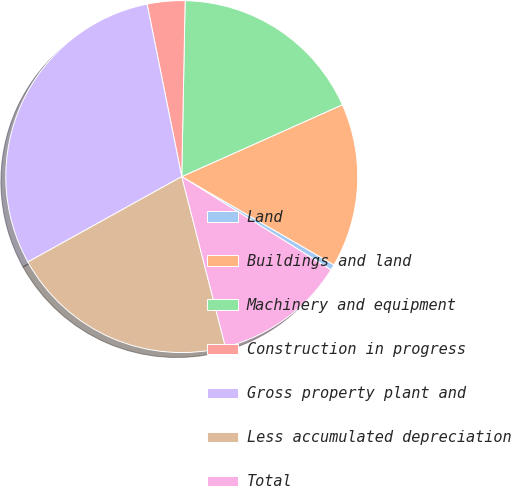<chart> <loc_0><loc_0><loc_500><loc_500><pie_chart><fcel>Land<fcel>Buildings and land<fcel>Machinery and equipment<fcel>Construction in progress<fcel>Gross property plant and<fcel>Less accumulated depreciation<fcel>Total<nl><fcel>0.52%<fcel>15.06%<fcel>18.0%<fcel>3.46%<fcel>29.91%<fcel>20.93%<fcel>12.12%<nl></chart> 